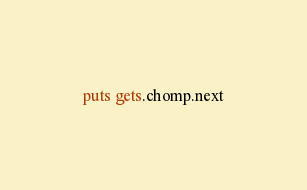Convert code to text. <code><loc_0><loc_0><loc_500><loc_500><_Ruby_>puts gets.chomp.next</code> 